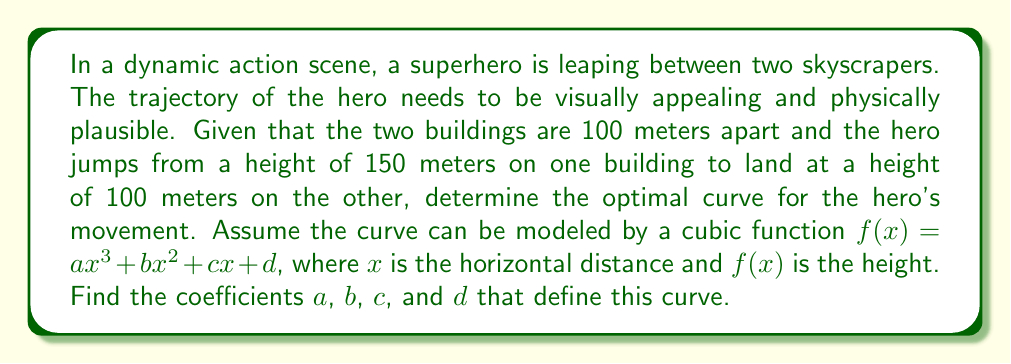Can you answer this question? To solve this problem, we'll follow these steps:

1) We know the following boundary conditions:
   At $x = 0$, $f(0) = 150$ (starting height)
   At $x = 100$, $f(100) = 100$ (ending height)

2) For a smooth trajectory, we also want the curve to be horizontal at the start and end points:
   At $x = 0$, $f'(0) = 0$
   At $x = 100$, $f'(100) = 0$

3) Let's write out these conditions using our cubic function:

   $f(0) = d = 150$
   $f(100) = a(100)^3 + b(100)^2 + c(100) + d = 100$
   $f'(x) = 3ax^2 + 2bx + c$
   $f'(0) = c = 0$
   $f'(100) = 3a(100)^2 + 2b(100) + c = 0$

4) From these equations, we can deduce:
   $d = 150$
   $c = 0$

5) Substituting these into the remaining equations:

   $1,000,000a + 10,000b + 150 = 100$
   $30,000a + 200b = 0$

6) Simplifying:

   $100a + b = -0.005$
   $150a + b = 0$

7) Subtracting the second equation from the first:

   $-50a = -0.005$
   $a = 0.0001$

8) Substituting this back into $150a + b = 0$:

   $150(0.0001) + b = 0$
   $b = -0.015$

Therefore, the coefficients are:
$a = 0.0001$
$b = -0.015$
$c = 0$
$d = 150$
Answer: $f(x) = 0.0001x^3 - 0.015x^2 + 150$ 